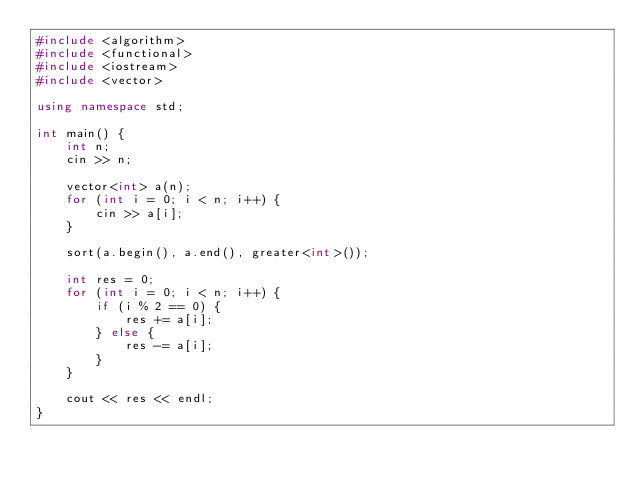Convert code to text. <code><loc_0><loc_0><loc_500><loc_500><_C++_>#include <algorithm>
#include <functional>
#include <iostream>
#include <vector>

using namespace std;

int main() {
    int n;
    cin >> n;

    vector<int> a(n);
    for (int i = 0; i < n; i++) {
        cin >> a[i];
    }

    sort(a.begin(), a.end(), greater<int>());

    int res = 0;
    for (int i = 0; i < n; i++) {
        if (i % 2 == 0) {
            res += a[i];
        } else {
            res -= a[i];
        }
    }

    cout << res << endl;
}
</code> 